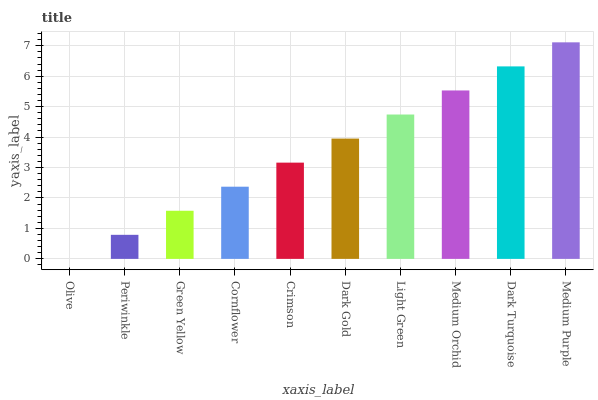Is Olive the minimum?
Answer yes or no. Yes. Is Medium Purple the maximum?
Answer yes or no. Yes. Is Periwinkle the minimum?
Answer yes or no. No. Is Periwinkle the maximum?
Answer yes or no. No. Is Periwinkle greater than Olive?
Answer yes or no. Yes. Is Olive less than Periwinkle?
Answer yes or no. Yes. Is Olive greater than Periwinkle?
Answer yes or no. No. Is Periwinkle less than Olive?
Answer yes or no. No. Is Dark Gold the high median?
Answer yes or no. Yes. Is Crimson the low median?
Answer yes or no. Yes. Is Crimson the high median?
Answer yes or no. No. Is Dark Gold the low median?
Answer yes or no. No. 